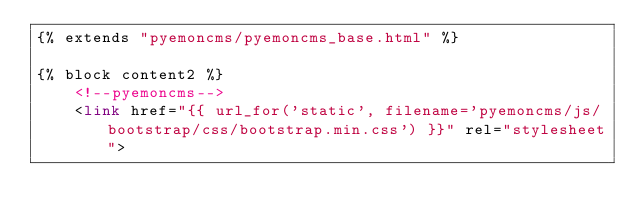Convert code to text. <code><loc_0><loc_0><loc_500><loc_500><_HTML_>{% extends "pyemoncms/pyemoncms_base.html" %}

{% block content2 %}
    <!--pyemoncms-->
    <link href="{{ url_for('static', filename='pyemoncms/js/bootstrap/css/bootstrap.min.css') }}" rel="stylesheet"></code> 